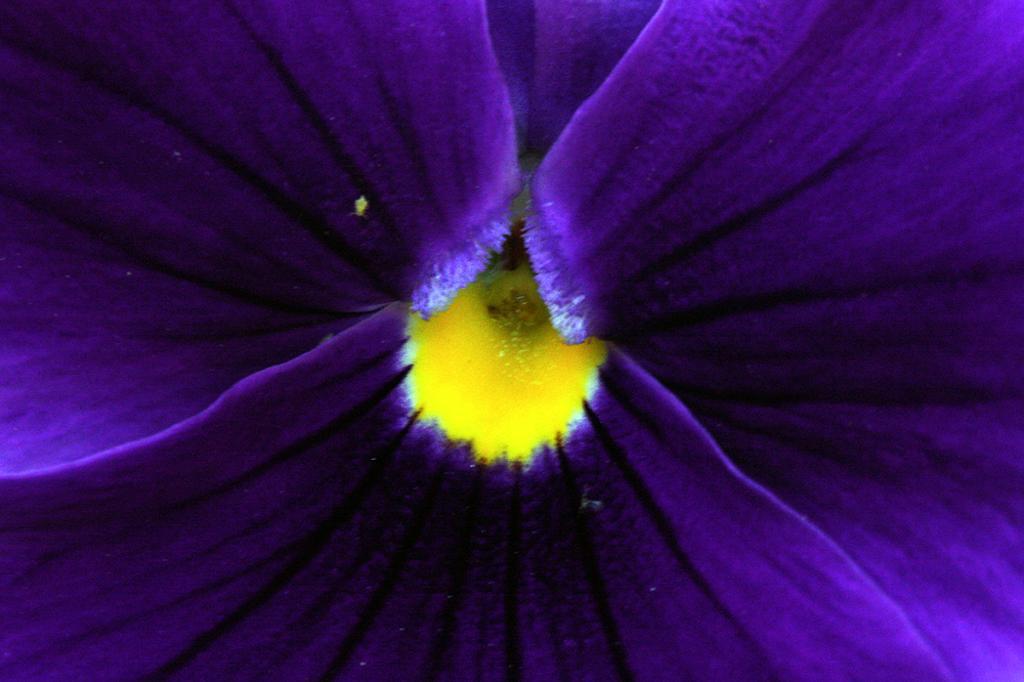In one or two sentences, can you explain what this image depicts? In this picture we can see a flower, we can see purple color petals here. 